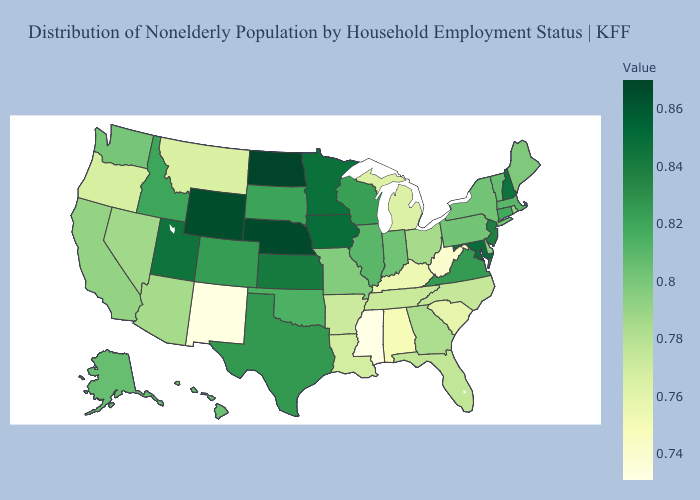Which states have the highest value in the USA?
Short answer required. North Dakota. Does Mississippi have the lowest value in the USA?
Give a very brief answer. Yes. Among the states that border Virginia , which have the highest value?
Write a very short answer. Maryland. Does Montana have a lower value than Mississippi?
Concise answer only. No. Does Arizona have a higher value than South Carolina?
Answer briefly. Yes. Does North Carolina have the lowest value in the USA?
Give a very brief answer. No. 